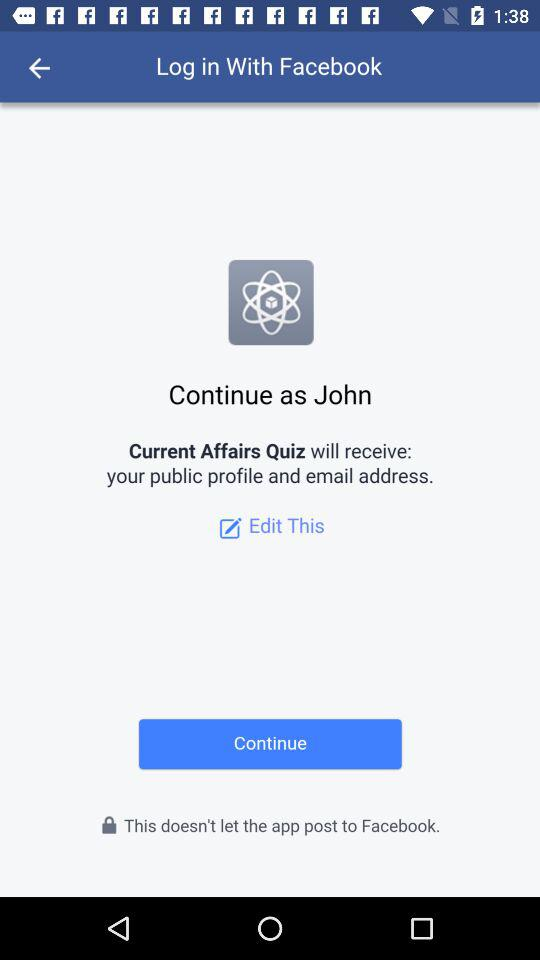What application is asking for permission? The application asking for permission is "Current Affairs Quiz". 